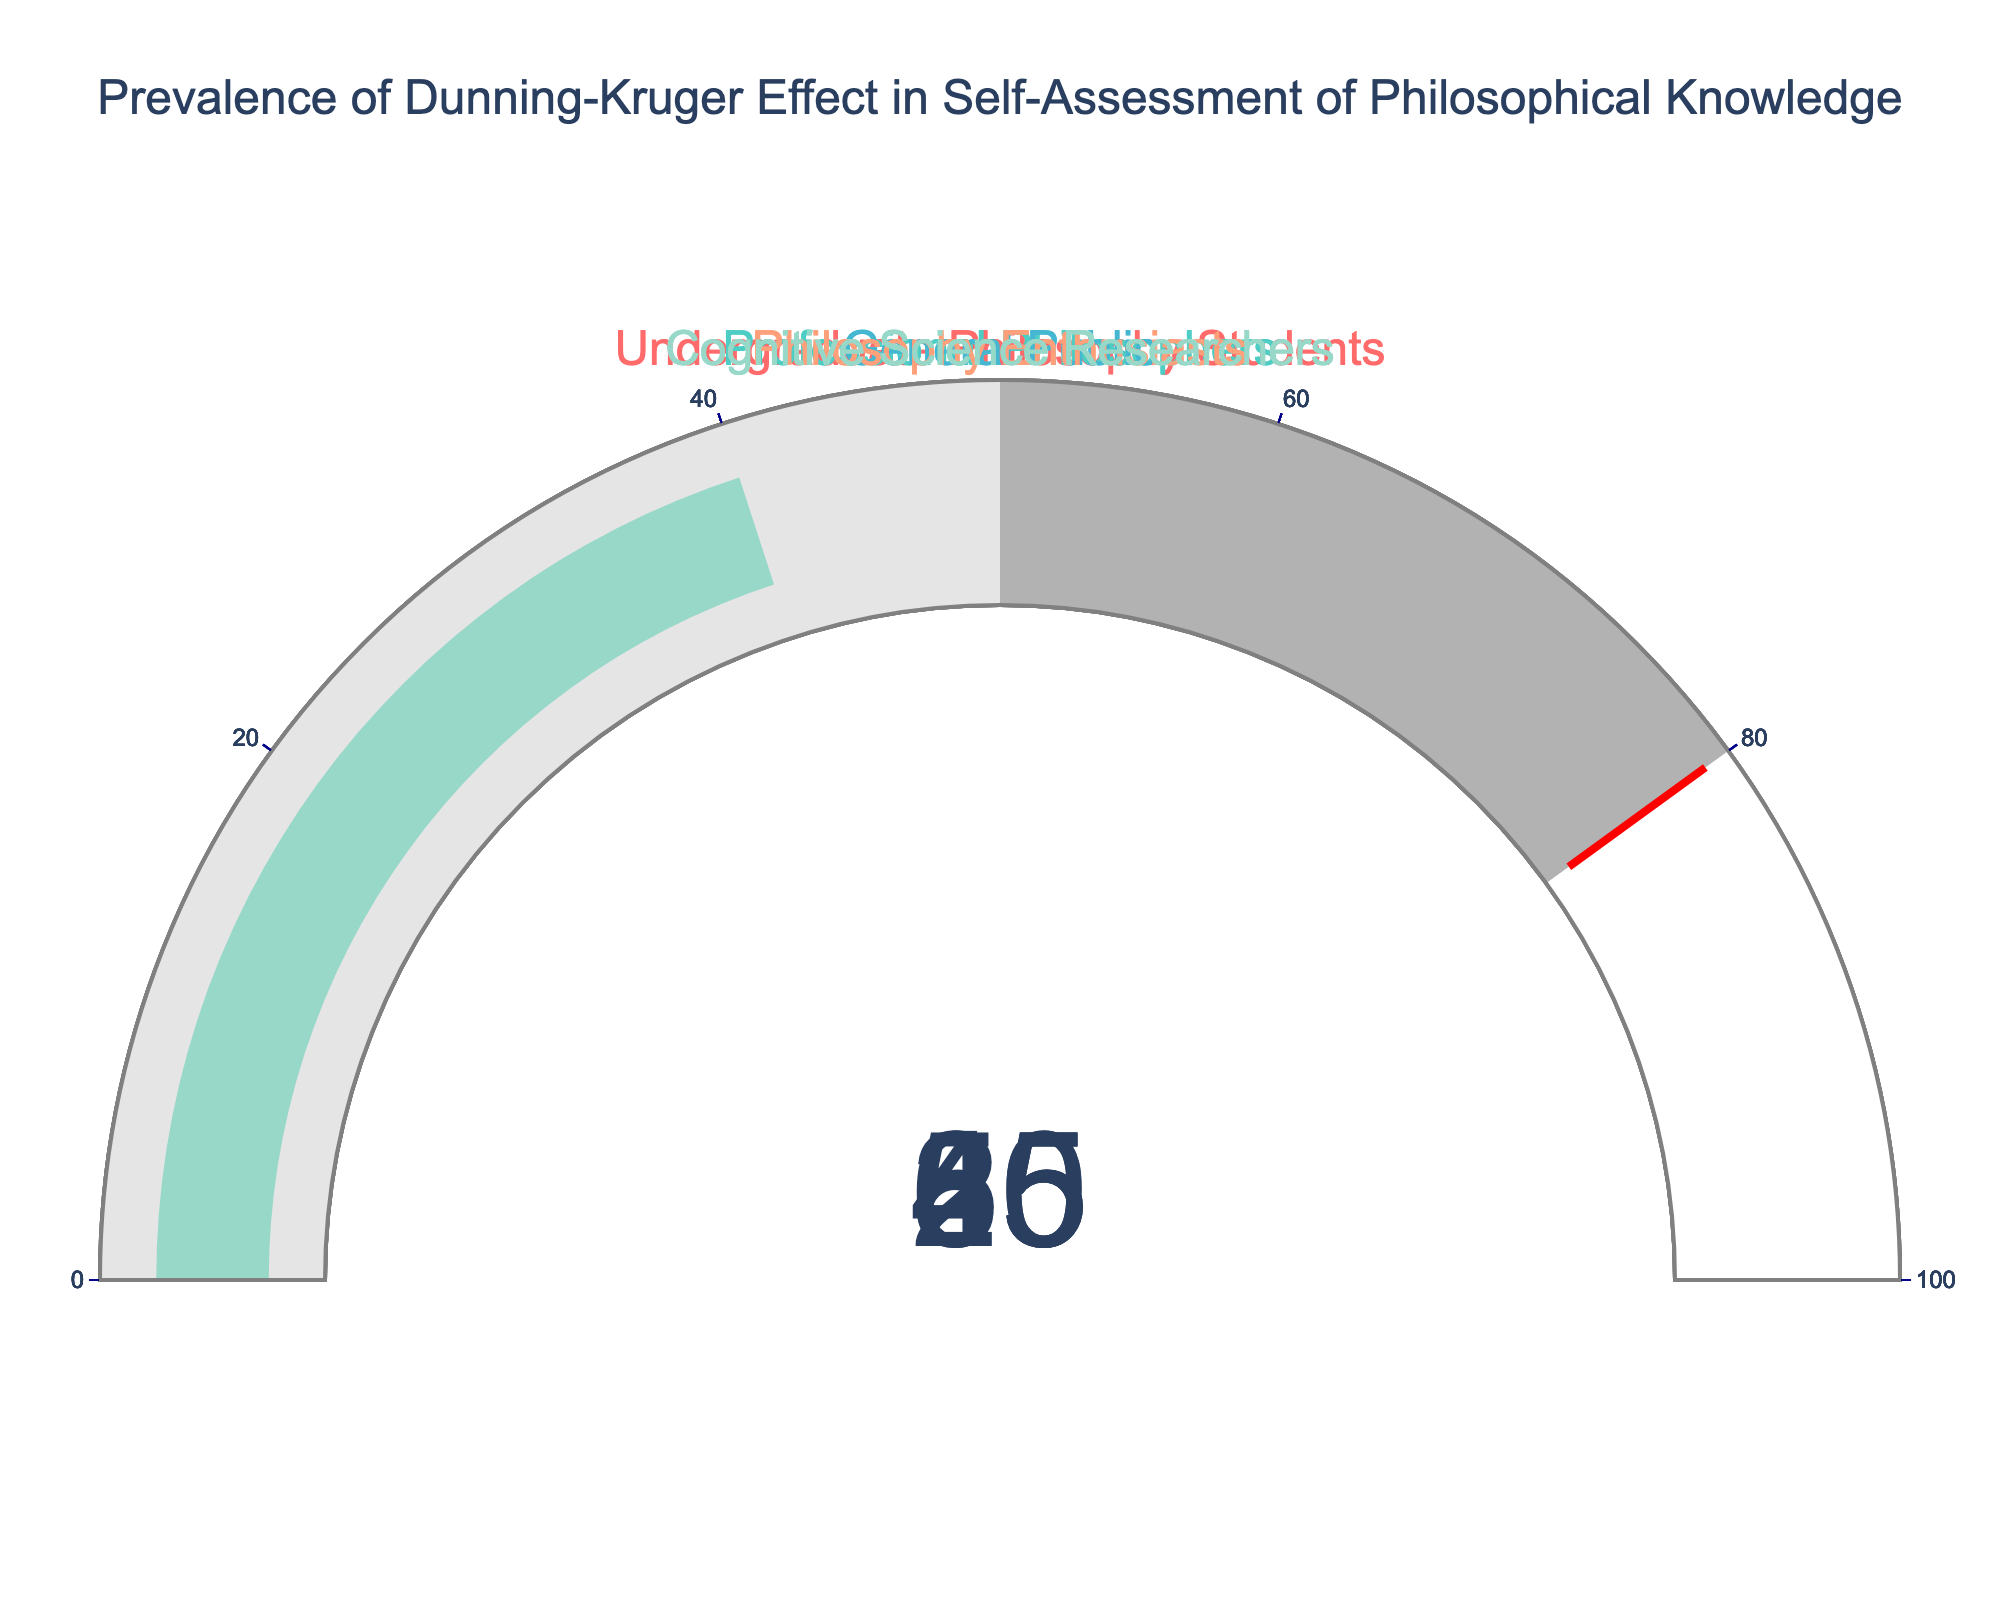what is the title of the chart? The title is the text at the top of the chart which typically indicates what the chart is displaying; in this case, it reads "Prevalence of Dunning-Kruger Effect in Self-Assessment of Philosophical Knowledge."
Answer: Prevalence of Dunning-Kruger Effect in Self-Assessment of Philosophical Knowledge Which group has the highest percentage? By looking at the gauge that reads the highest value, we can identify that the "General Public" group displays a value of 80%, which is the highest on the chart.
Answer: General Public What is the percentage for professional philosophers? The gauge labeled "Professional Philosophers" shows a value; in this case, it is specifically 25%.
Answer: 25% What is the average percentage across all groups shown? To find the average, sum all the percentages: 65% + 25% + 80% + 55% + 40% = 265%, then divide by the number of groups, which is 5. Thus, 265/5 = 53%.
Answer: 53% Which group has the lowest percentage? By observing the gauge that reads the lowest value, we can identify that the "Professional Philosophers" group displays a value of 25%, which is the lowest on the chart.
Answer: Professional Philosophers Is the percentage of Cognitive Science Researchers higher than that of Philosophy Enthusiasts? By comparing the values displayed on the gauges, we see that the "Cognitive Science Researchers" have a value of 40%, while the "Philosophy Enthusiasts" have a value of 55%. Therefore, 40% is not higher than 55%.
Answer: No What is the sum of the percentages of Undergraduate Philosophy Students and Philosophy Enthusiasts? Add together the percentages displayed for both groups, which are 65% and 55% respectively: 65 + 55 = 120%.
Answer: 120% How many groups have a percentage that is above the average? First, we determined the average to be 53%. Now, we count the groups that have percentages above this value: Undergraduate Philosophy Students (65%), General Public (80%), and Philosophy Enthusiasts (55%). There are three groups.
Answer: 3 